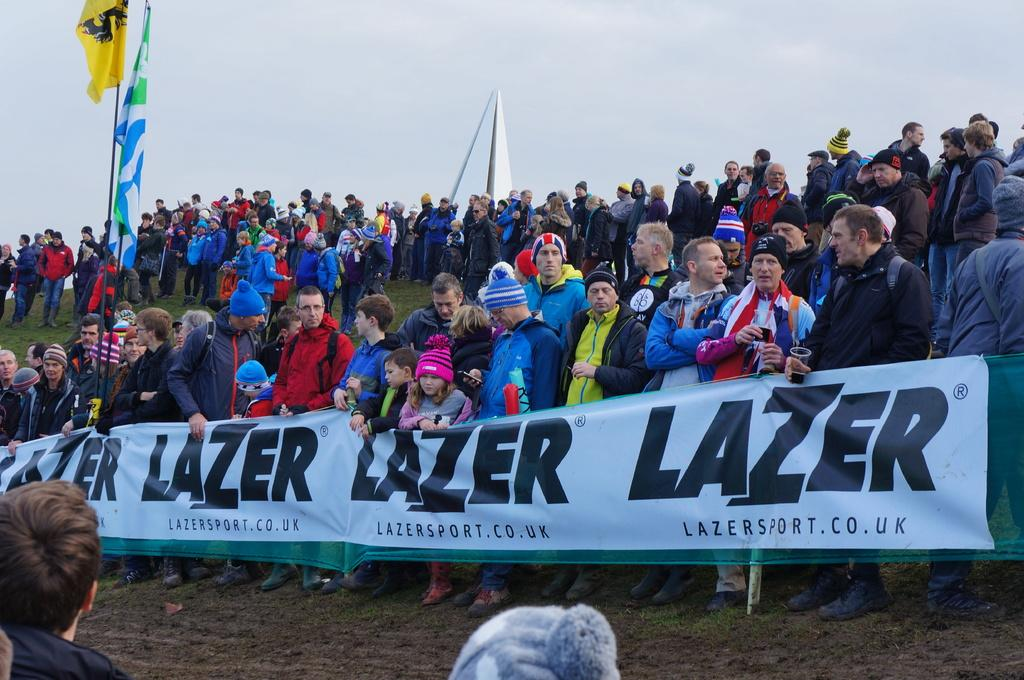Who or what can be seen in the image? There are people in the image. What are some of the people doing in the image? Some people are carrying banners in the image. Are there any other objects or symbols present in the image? Yes, there are flags in the image. What can be seen in the background of the image? The sky is visible in the background of the image. What type of potato is being used as a cap in the image? There is no potato or cap present in the image. 